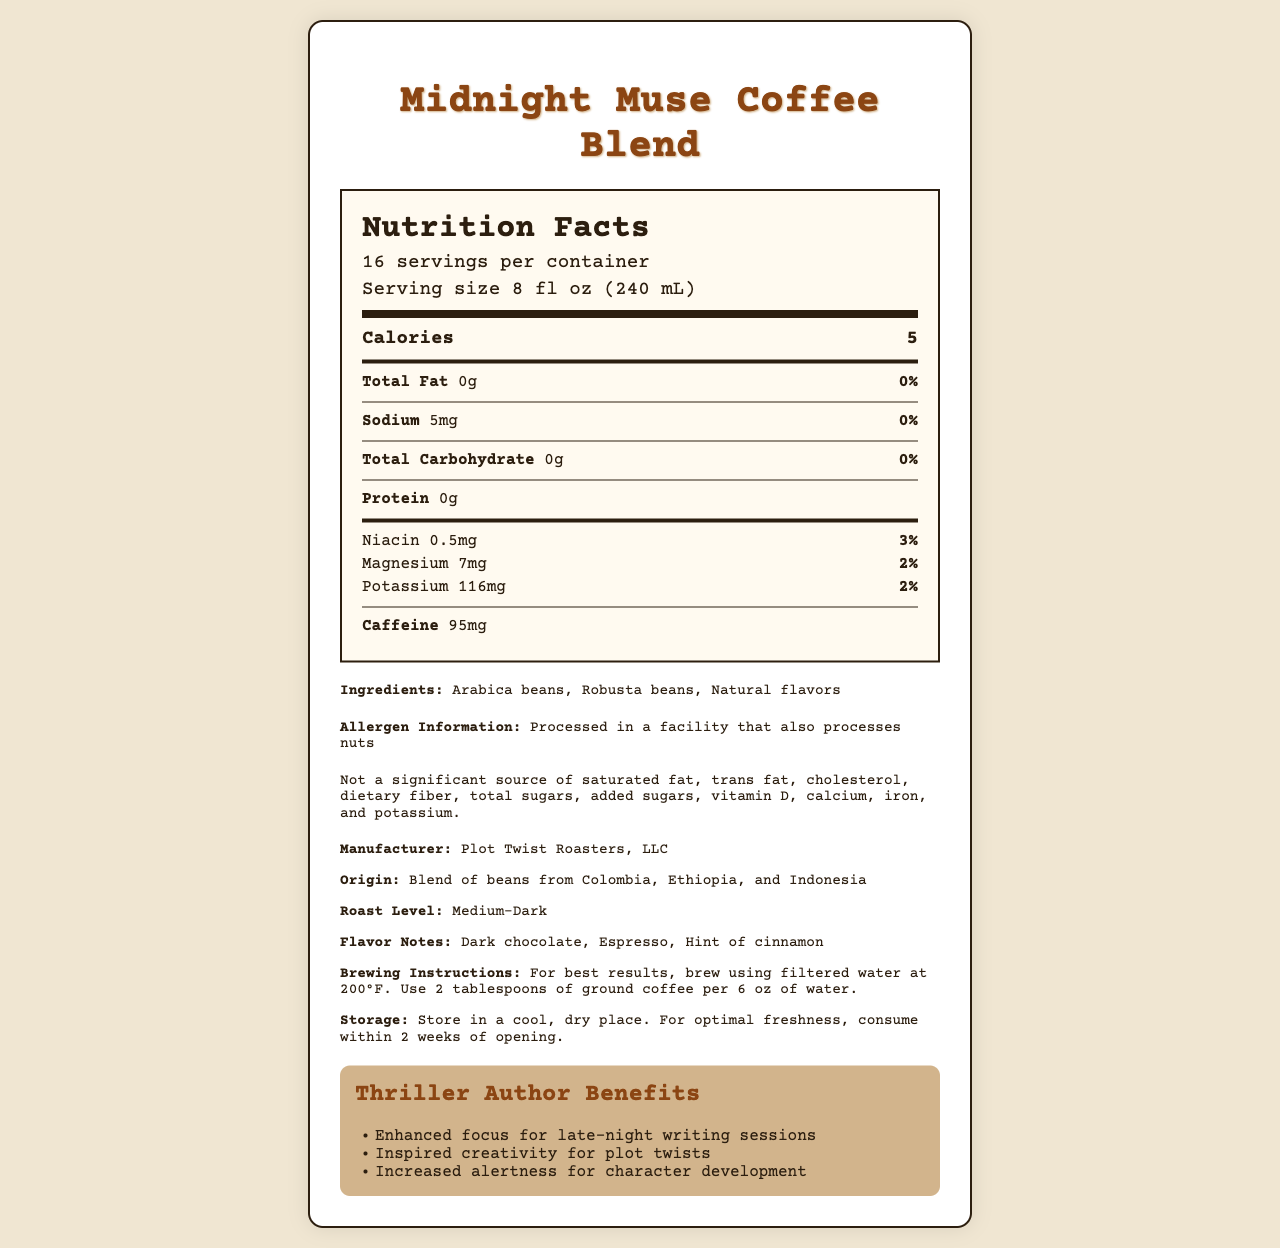what is the serving size of Midnight Muse Coffee Blend? The serving size is listed at the top of the nutrition label as "8 fl oz (240 mL)".
Answer: 8 fl oz (240 mL) how many servings are there per container? The label states "16 servings per container" right beneath the product name.
Answer: 16 how many calories are there per serving? The calories per serving are clearly indicated as "5" on the nutrition label.
Answer: 5 what is the amount of protein per serving? The label under the "Total Carbohydrate" section specifies 0g of protein.
Answer: 0g what vitamins and minerals does the coffee contain? The vitamins and minerals section lists Niacin, Magnesium, and Potassium among the nutrients.
Answer: Niacin, Magnesium, Potassium which type of beans are used in this coffee blend? The ingredients section mentions that the blend contains Arabica beans and Robusta beans.
Answer: Arabica beans, Robusta beans what is the caffeine content per serving? The label states that each serving of coffee contains 95mg of caffeine.
Answer: 95mg what benefits does the coffee provide specifically for thriller authors? The "Thriller Author Benefits" section lists these three benefits.
Answer: Enhanced focus for late-night writing sessions, Inspired creativity for plot twists, Increased alertness for character development which company manufactures the Midnight Muse Coffee Blend? A. Midnight Roasters B. Plot Twist Roasters, LLC C. Thriller Beans Inc. The document indicates that the manufacturer is "Plot Twist Roasters, LLC".
Answer: B what flavor notes does the coffee have? A. Dark chocolate, Vanilla B. Espresso, Cherry C. Dark chocolate, Espresso, Hint of cinnamon The flavor notes listed in the additional information are "Dark chocolate, Espresso, Hint of cinnamon".
Answer: C is the Midnight Muse Coffee Blend suitable for someone with nut allergies? The label includes an allergen information section that states the product is processed in a facility that also processes nuts.
Answer: No summarize the main idea of the Midnight Muse Coffee Blend's nutrition label. The document describes the nutritional content, ingredients, and specific benefits for thriller authors and includes details on calories, caffeine content, vitamins, and allergens, as well as manufacturer and brewing instructions.
Answer: Midnight Muse Coffee Blend is a gourmet coffee designed for thriller authors, offering low-calorie servings with a medium-dark roast and flavor notes of dark chocolate, espresso, and cinnamon. It provides benefits such as enhanced focus, creativity, and alertness. what is the source of the natural flavors in the coffee blend? The document does not specify the source of the natural flavors in the ingredients list.
Answer: Cannot be determined 